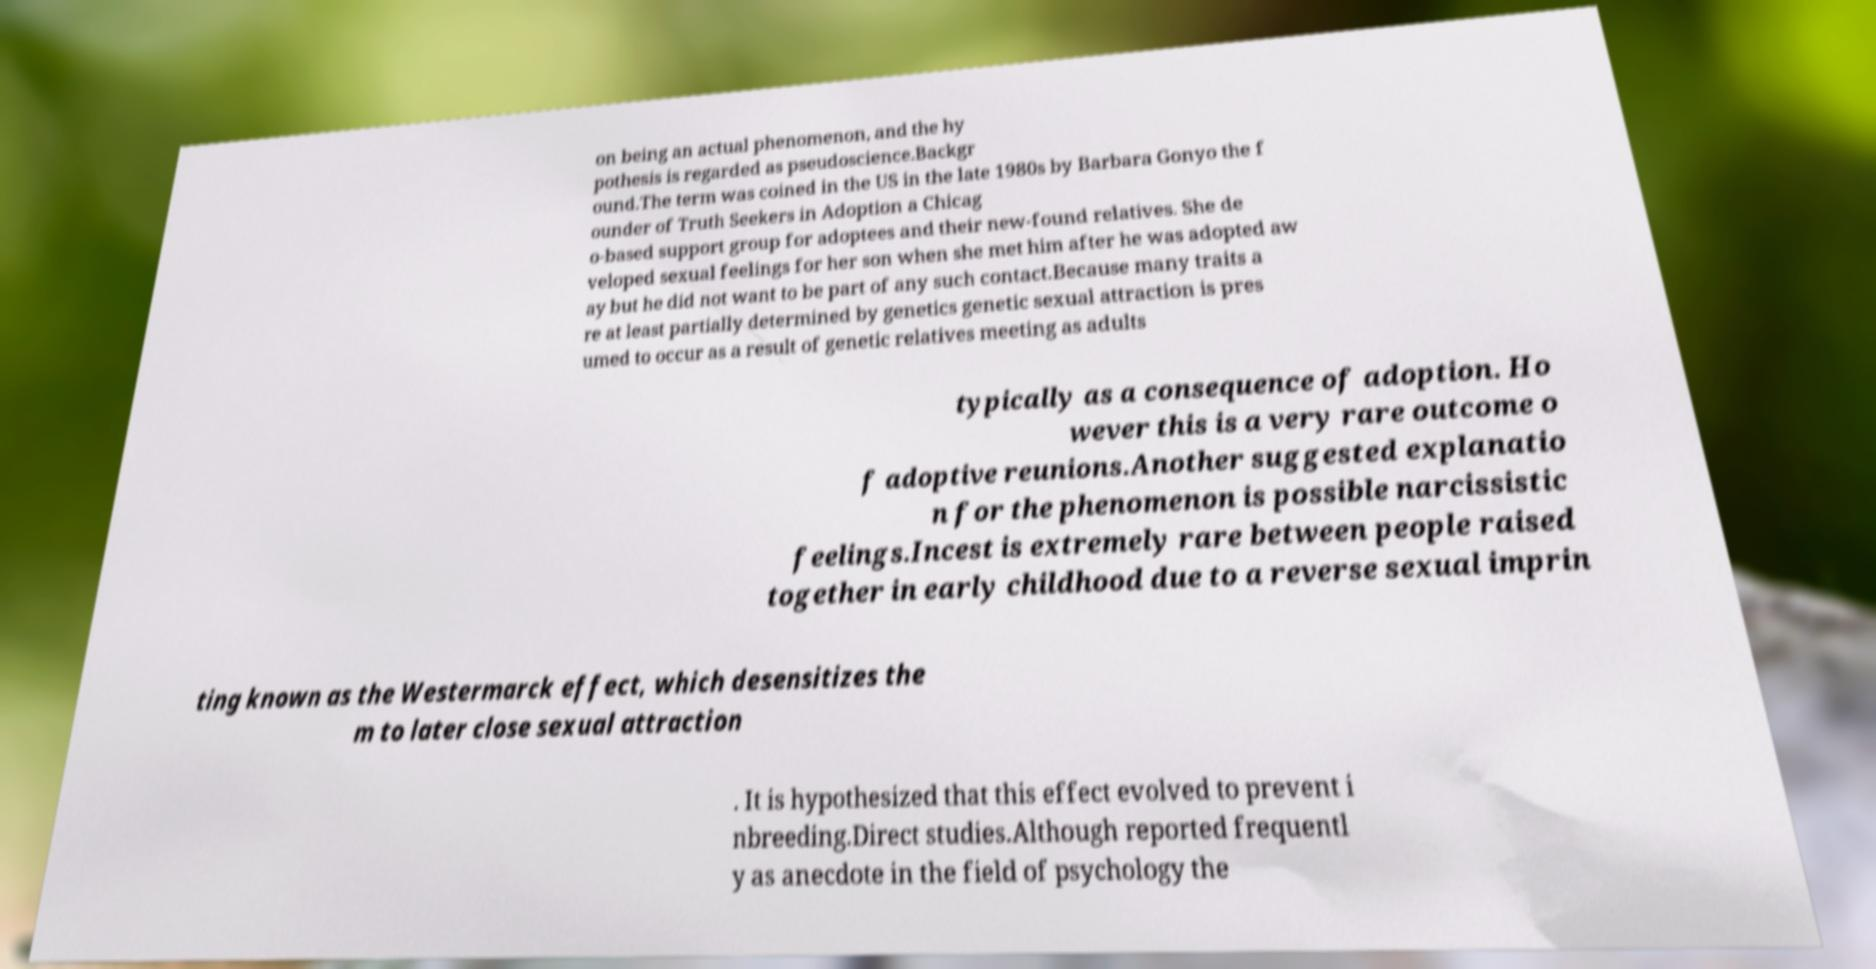I need the written content from this picture converted into text. Can you do that? on being an actual phenomenon, and the hy pothesis is regarded as pseudoscience.Backgr ound.The term was coined in the US in the late 1980s by Barbara Gonyo the f ounder of Truth Seekers in Adoption a Chicag o-based support group for adoptees and their new-found relatives. She de veloped sexual feelings for her son when she met him after he was adopted aw ay but he did not want to be part of any such contact.Because many traits a re at least partially determined by genetics genetic sexual attraction is pres umed to occur as a result of genetic relatives meeting as adults typically as a consequence of adoption. Ho wever this is a very rare outcome o f adoptive reunions.Another suggested explanatio n for the phenomenon is possible narcissistic feelings.Incest is extremely rare between people raised together in early childhood due to a reverse sexual imprin ting known as the Westermarck effect, which desensitizes the m to later close sexual attraction . It is hypothesized that this effect evolved to prevent i nbreeding.Direct studies.Although reported frequentl y as anecdote in the field of psychology the 